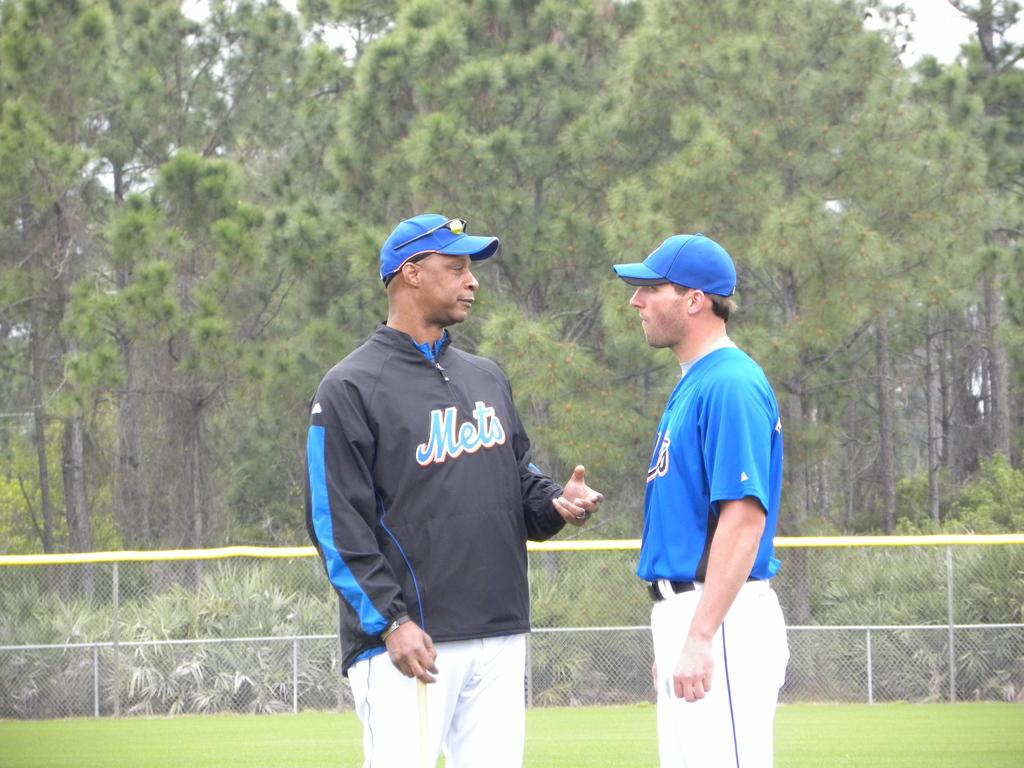<image>
Offer a succinct explanation of the picture presented. The man in the black top has the team mets on the front. 